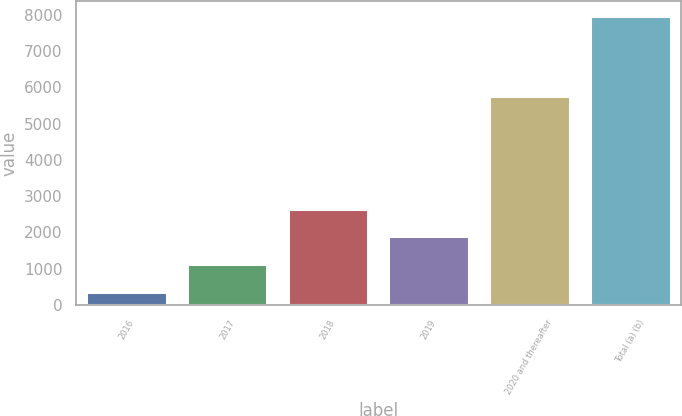Convert chart. <chart><loc_0><loc_0><loc_500><loc_500><bar_chart><fcel>2016<fcel>2017<fcel>2018<fcel>2019<fcel>2020 and thereafter<fcel>Total (a) (b)<nl><fcel>369<fcel>1129.6<fcel>2650.8<fcel>1890.2<fcel>5758<fcel>7975<nl></chart> 